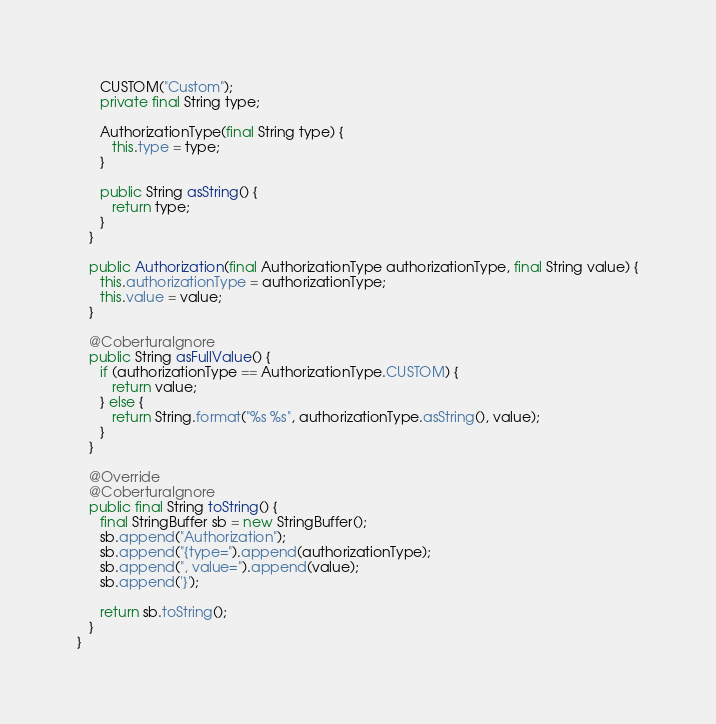Convert code to text. <code><loc_0><loc_0><loc_500><loc_500><_Java_>      CUSTOM("Custom");
      private final String type;

      AuthorizationType(final String type) {
         this.type = type;
      }

      public String asString() {
         return type;
      }
   }

   public Authorization(final AuthorizationType authorizationType, final String value) {
      this.authorizationType = authorizationType;
      this.value = value;
   }

   @CoberturaIgnore
   public String asFullValue() {
      if (authorizationType == AuthorizationType.CUSTOM) {
         return value;
      } else {
         return String.format("%s %s", authorizationType.asString(), value);
      }
   }

   @Override
   @CoberturaIgnore
   public final String toString() {
      final StringBuffer sb = new StringBuffer();
      sb.append("Authorization");
      sb.append("{type=").append(authorizationType);
      sb.append(", value=").append(value);
      sb.append('}');

      return sb.toString();
   }
}
</code> 